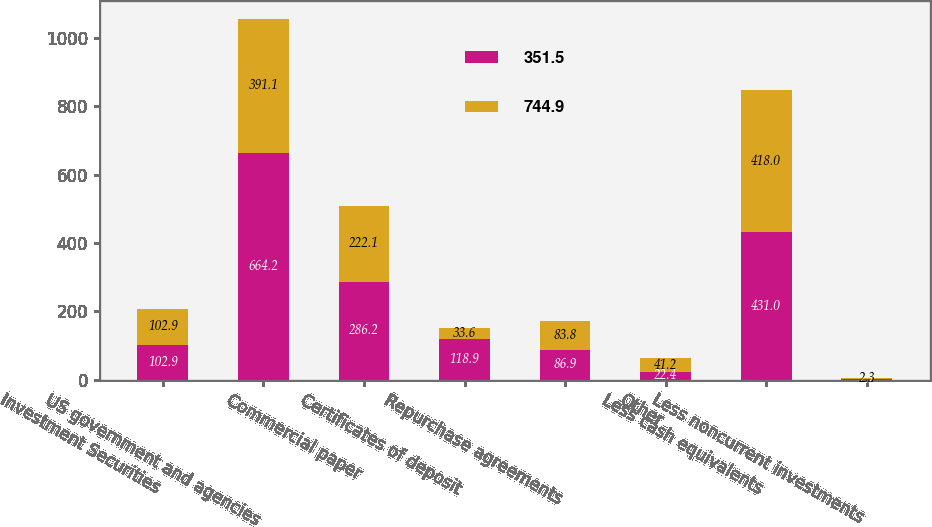<chart> <loc_0><loc_0><loc_500><loc_500><stacked_bar_chart><ecel><fcel>Investment Securities<fcel>US government and agencies<fcel>Commercial paper<fcel>Certificates of deposit<fcel>Repurchase agreements<fcel>Other<fcel>Less cash equivalents<fcel>Less noncurrent investments<nl><fcel>351.5<fcel>102.9<fcel>664.2<fcel>286.2<fcel>118.9<fcel>86.9<fcel>22.4<fcel>431<fcel>2.7<nl><fcel>744.9<fcel>102.9<fcel>391.1<fcel>222.1<fcel>33.6<fcel>83.8<fcel>41.2<fcel>418<fcel>2.3<nl></chart> 